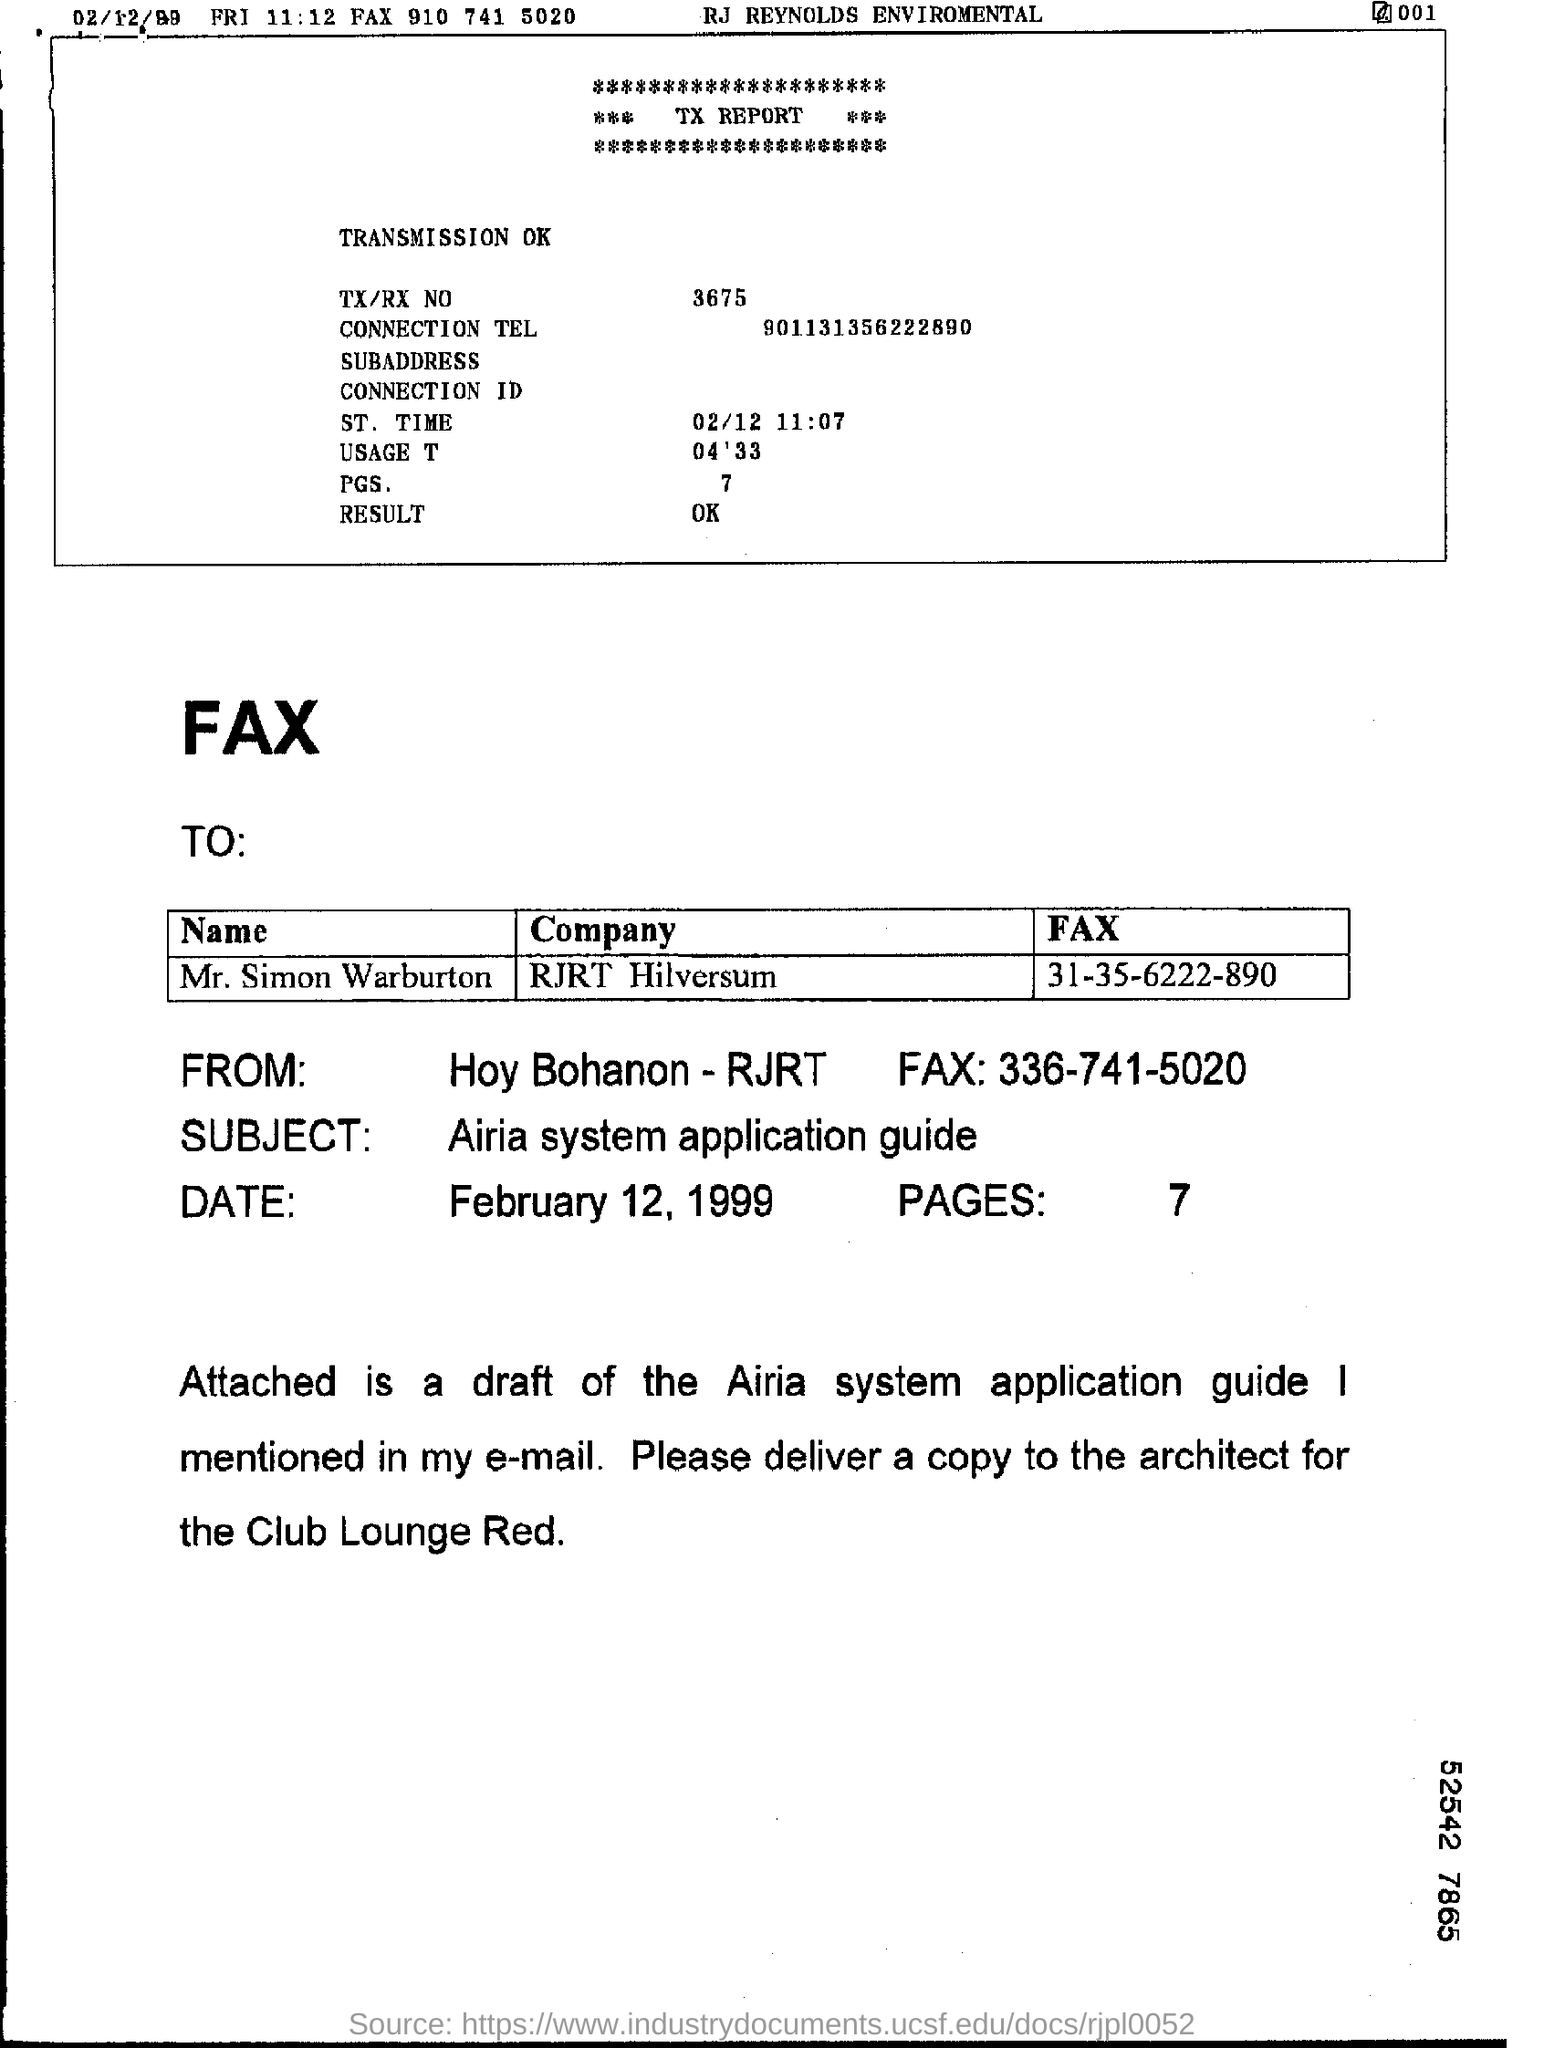What is the tx/rx no mentioned in the tx report ?
Make the answer very short. 3675. What is the st.time given in the tx report ?
Ensure brevity in your answer.  02/12  11:07. How many pages are mentioned in the tx report ?
Keep it short and to the point. 7. What is the connection tel given in the tx report ?
Offer a terse response. 901131356222890. What is the usage time given in the tx report ?
Offer a very short reply. 04'33. To which company the fax was written ?
Make the answer very short. RJRT Hilversum. How many pages are there in the fax ?
Your answer should be very brief. 7. What is the subject mentioned in the fax ?
Give a very brief answer. Airia system application guide. 